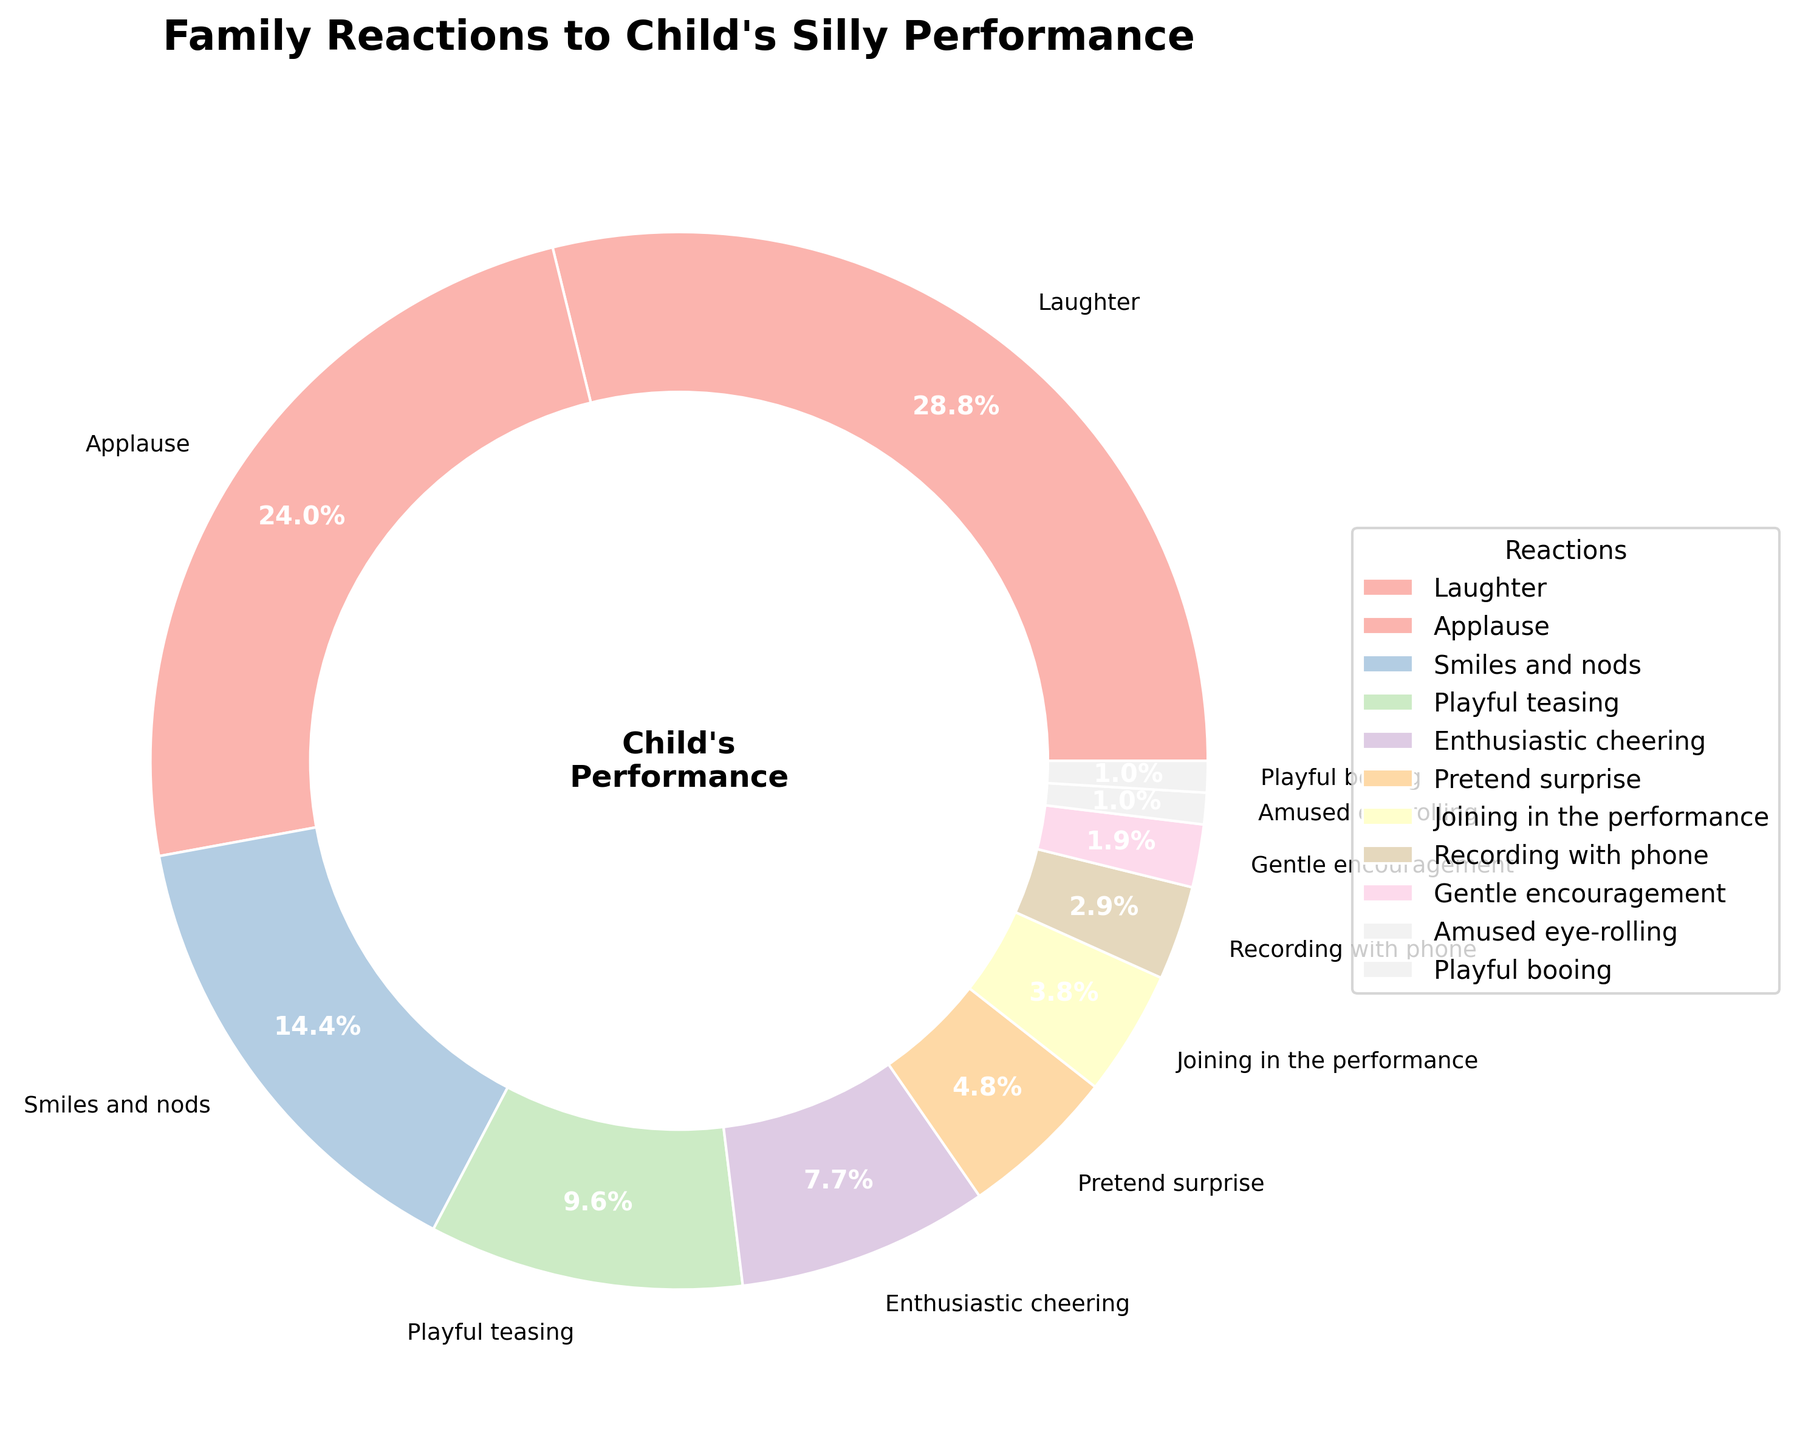Which reaction has the highest percentage? The largest segment in the pie chart corresponds to 'Laughter,' which has a percentage of 30%.
Answer: Laughter Which reactions combined make up 50% of the total reactions? 'Laughter' (30%) and 'Applause' (25%) together make up 55%, which exceeds 50%. Therefore, the first two reactions combined already exceed 50%.
Answer: Laughter and Applause What is the difference in percentage between 'Smiles and nods' and 'Playful teasing'? 'Smiles and nods' have a percentage of 15%, and 'Playful teasing' has a percentage of 10%. The difference is 15% - 10% = 5%.
Answer: 5% How many reactions have a percentage greater than 10%? The reactions 'Laughter' (30%), 'Applause' (25%), and 'Smiles and nods' (15%) each have percentages greater than 10%. This totals 3 reactions.
Answer: 3 Which reaction has a smaller percentage, 'Vacation' or 'Smiles and nods'? 'Smiles and nods' has a percentage of 15%, whereas 'Vacation' (Playful teasing) has a percentage of 10%. Therefore, 'Playful teasing' is smaller.
Answer: Playful teasing What is the combined percentage of 'Pretend surprise,' 'Joining in the performance,' and 'Recording with phone'? 'Pretend surprise' is 5%, 'Joining in the performance' is 4%, and 'Recording with phone' is 3%. The combined percentage is 5% + 4% + 3% = 12%.
Answer: 12% What percentage of reactions involve active participation ('Joining in the performance' and 'Recording with phone')? 'Joining in the performance' has a percentage of 4%, and 'Recording with phone' has a percentage of 3%. Therefore, the total percentage for active participation is 4% + 3% = 7%.
Answer: 7% Rank the reactions with percentages less than 5% from highest to lowest. The reactions with percentages less than 5% are 'Pretend surprise' (5%), 'Joining in the performance' (4%), 'Recording with phone' (3%), 'Gentle encouragement' (2%), 'Amused eye-rolling' (1%), and 'Playful booing' (1%). The rank order is: 'Pretend surprise' > 'Joining in the performance' > 'Recording with phone' > 'Gentle encouragement' > 'Amused eye-rolling' = 'Playful booing'.
Answer: Pretend surprise, Joining in the performance, Recording with phone, Gentle encouragement, Amused eye-rolling, Playful booing 